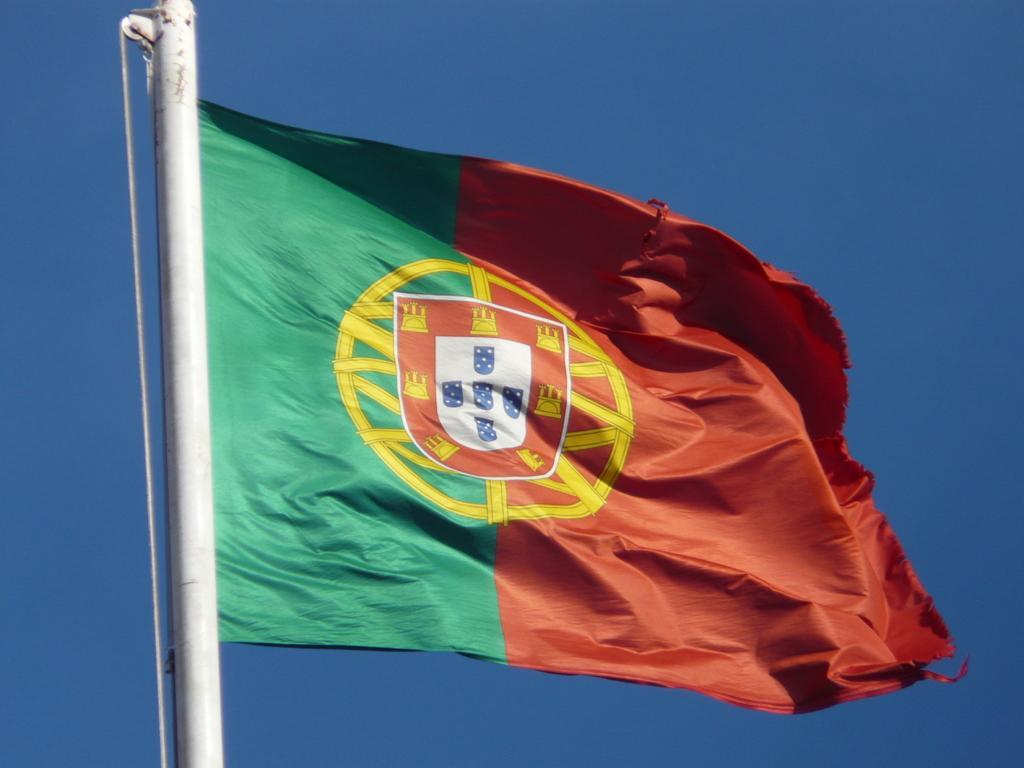Please provide a concise description of this image. In this image there is a Flag with green and red color. There is a sky. 